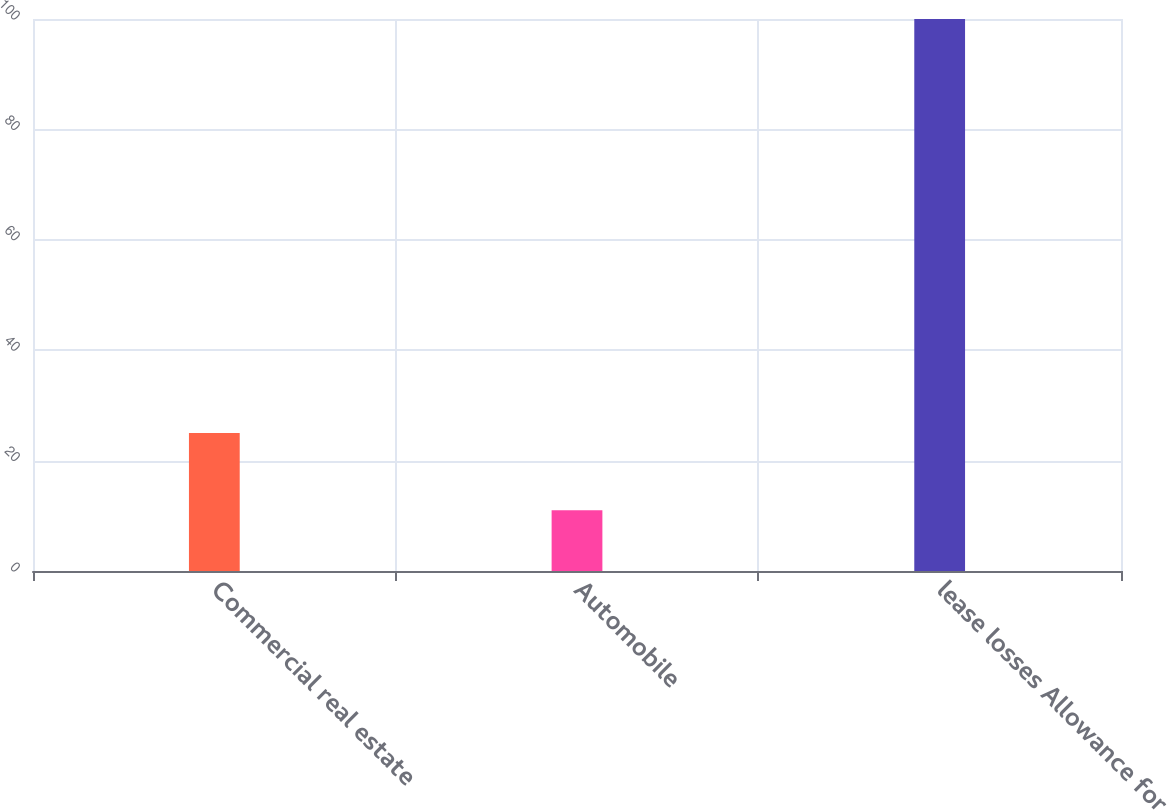<chart> <loc_0><loc_0><loc_500><loc_500><bar_chart><fcel>Commercial real estate<fcel>Automobile<fcel>lease losses Allowance for<nl><fcel>25<fcel>11<fcel>100<nl></chart> 